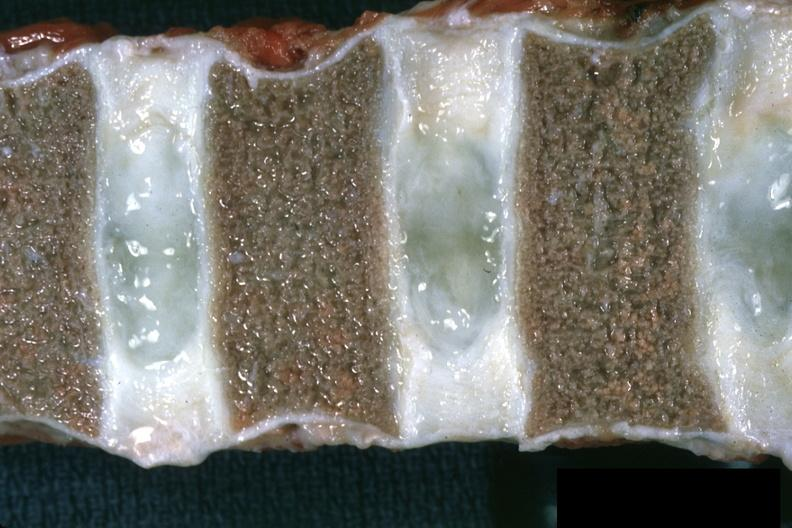what is present?
Answer the question using a single word or phrase. Joints 